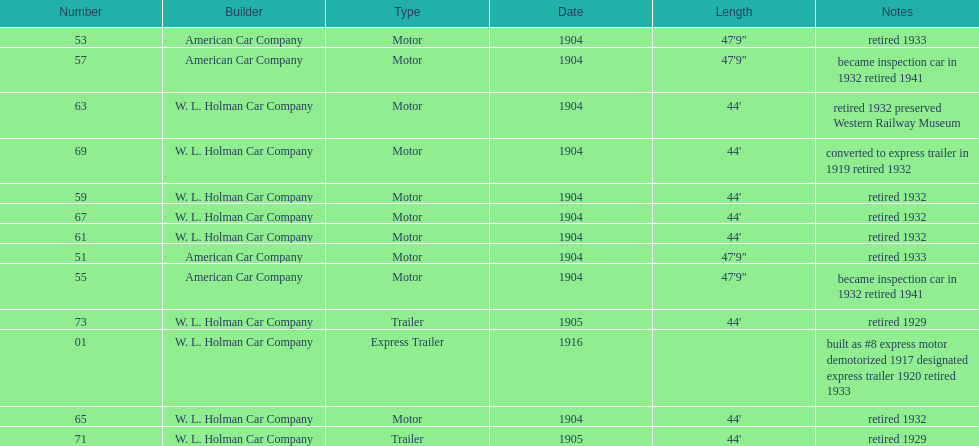In 1906, how many total rolling stock vehicles were in service? 12. 